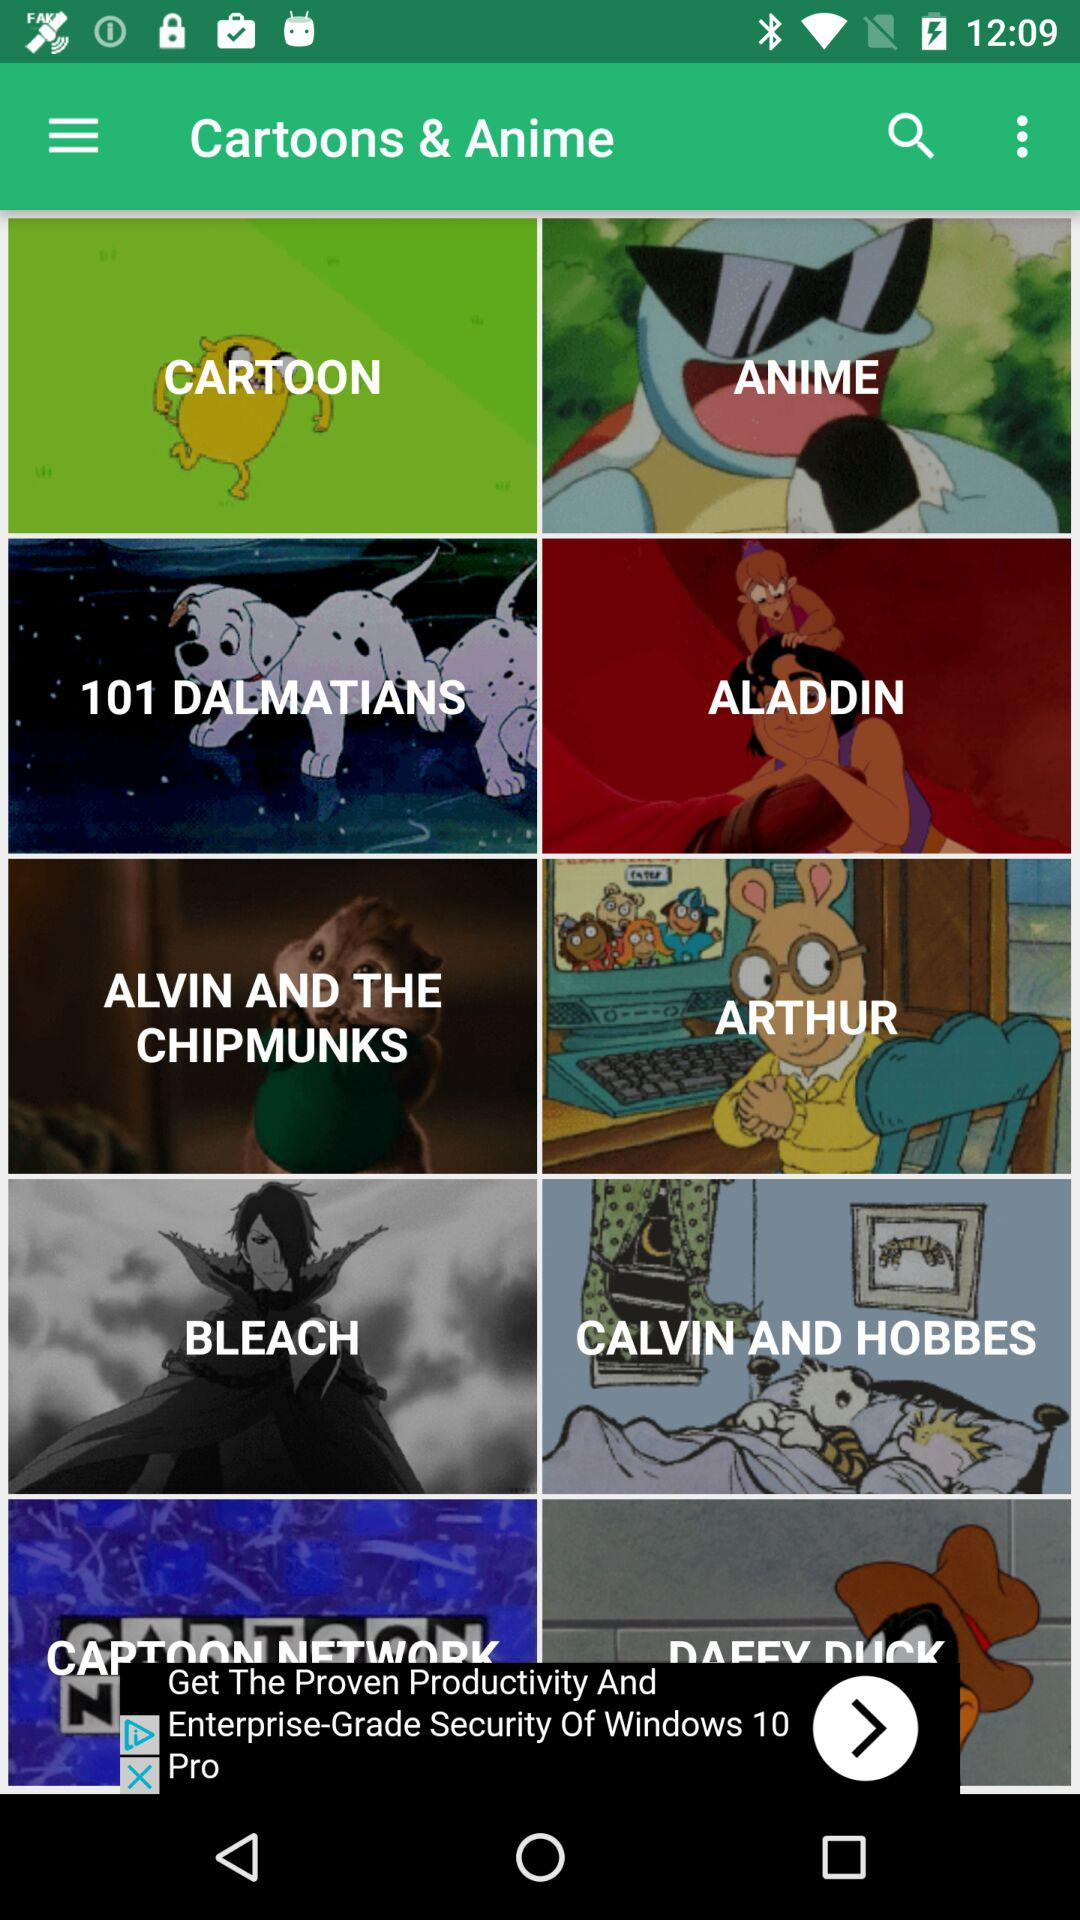What is the application name?
When the provided information is insufficient, respond with <no answer>. <no answer> 